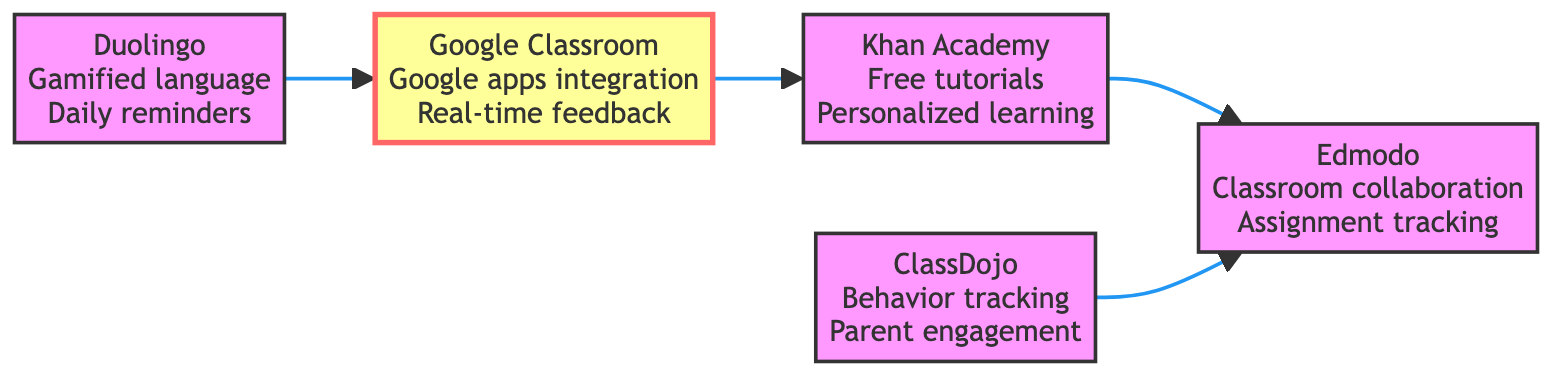What are the features of Khan Academy? The diagram lists the features of Khan Academy as "Free tutorials", "Personalized learning dashboard", and "Wide range of subjects".
Answer: Free tutorials, Personalized learning dashboard, Wide range of subjects How many nodes are in the diagram? The diagram includes five distinct nodes: Khan Academy, Duolingo, Edmodo, ClassDojo, and Google Classroom, hence the total is five.
Answer: 5 Which platform has a feedback comment indicating it is user-friendly? The feedback for Google Classroom states that it has a "User-friendly interface", making it the platform with this specific feedback.
Answer: Google Classroom What is the directed edge from Duolingo to? The diagram shows that there is a directed edge from Duolingo that points to Google Classroom, indicating a relationship between these two platforms.
Answer: Google Classroom Which platforms provide collaboration tools? The features listed for Edmodo include "Classroom collaboration tools", making it the only platform explicitly identified for this.
Answer: Edmodo How many features does ClassDojo have? ClassDojo has three specified features: "Behavior tracking", "Classroom stories", and "Parent engagement tools", resulting in a total of three features.
Answer: 3 What feedback do parents give about Duolingo? In the diagram, the feedback from parents about Duolingo indicates that it is "Engaging for children" which conveys positive parental sentiment.
Answer: Engaging for children Which platform connects directly to both Khan Academy and Edmodo? The flow indicates that Google Classroom connects to both Khan Academy and Edmodo, showing that it has a direct relationship with them.
Answer: Google Classroom What feature is highlighted for Google Classroom? The feature highlighted for Google Classroom is "Seamless integration with Google apps", indicating a key aspect of its functionality.
Answer: Seamless integration with Google apps 